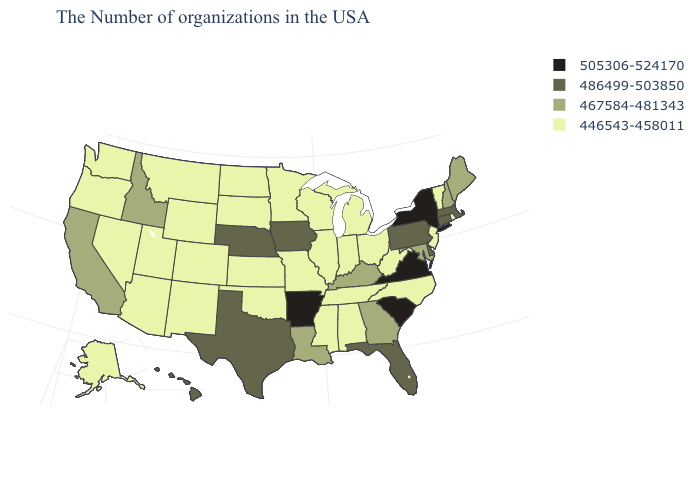Among the states that border South Carolina , does Georgia have the highest value?
Short answer required. Yes. Does Kansas have the lowest value in the USA?
Be succinct. Yes. Among the states that border Michigan , which have the highest value?
Quick response, please. Ohio, Indiana, Wisconsin. What is the value of Alaska?
Answer briefly. 446543-458011. Does New York have the highest value in the USA?
Write a very short answer. Yes. How many symbols are there in the legend?
Short answer required. 4. What is the value of California?
Keep it brief. 467584-481343. Name the states that have a value in the range 505306-524170?
Give a very brief answer. New York, Virginia, South Carolina, Arkansas. What is the lowest value in the USA?
Short answer required. 446543-458011. Among the states that border New York , which have the highest value?
Be succinct. Massachusetts, Connecticut, Pennsylvania. Name the states that have a value in the range 446543-458011?
Short answer required. Rhode Island, Vermont, New Jersey, North Carolina, West Virginia, Ohio, Michigan, Indiana, Alabama, Tennessee, Wisconsin, Illinois, Mississippi, Missouri, Minnesota, Kansas, Oklahoma, South Dakota, North Dakota, Wyoming, Colorado, New Mexico, Utah, Montana, Arizona, Nevada, Washington, Oregon, Alaska. Among the states that border Pennsylvania , which have the highest value?
Short answer required. New York. What is the lowest value in the South?
Be succinct. 446543-458011. Is the legend a continuous bar?
Short answer required. No. What is the value of Maryland?
Answer briefly. 467584-481343. 